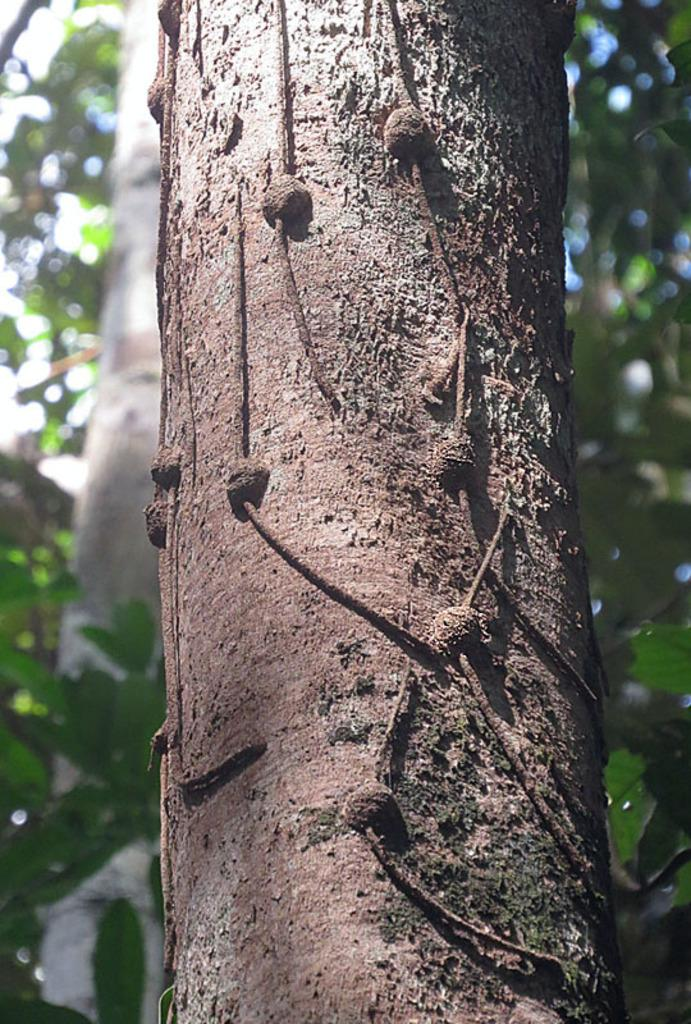What is the main subject of the image? The main subject of the image is a tree trunk. Can you describe the surrounding environment in the image? There are trees in the background of the image. How many flowers are on the tree trunk in the image? There are no flowers present on the tree trunk in the image. How do the pigs balance on the tree trunk in the image? There are no pigs present in the image, so they cannot be balancing on the tree trunk. 